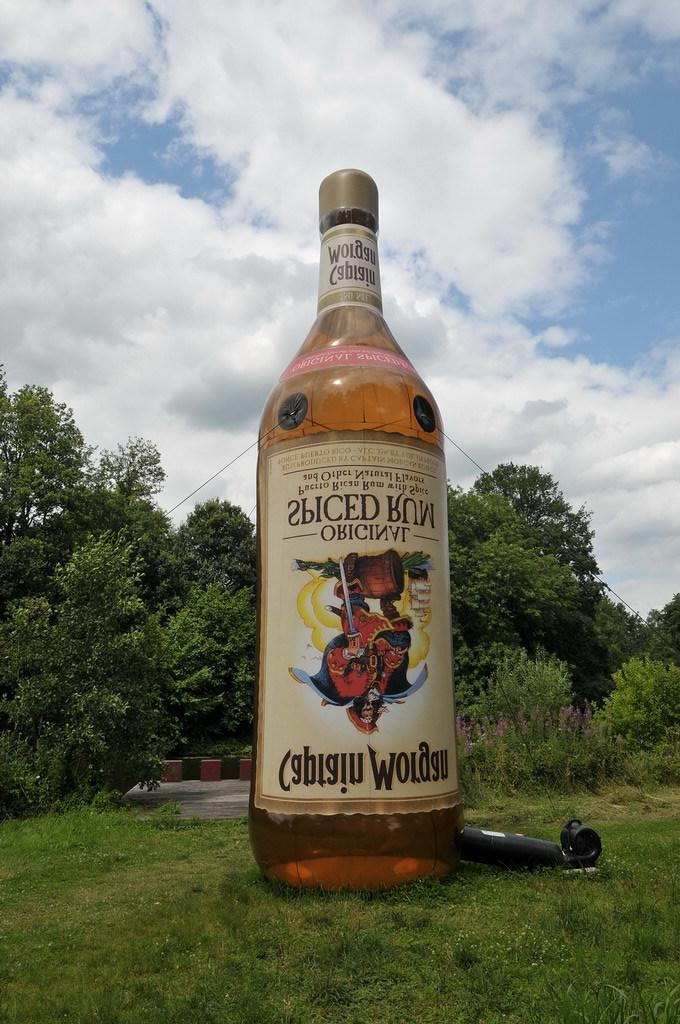<image>
Provide a brief description of the given image. A huge blow-up bottle of Captain Morgan beer is shown on the grass. 